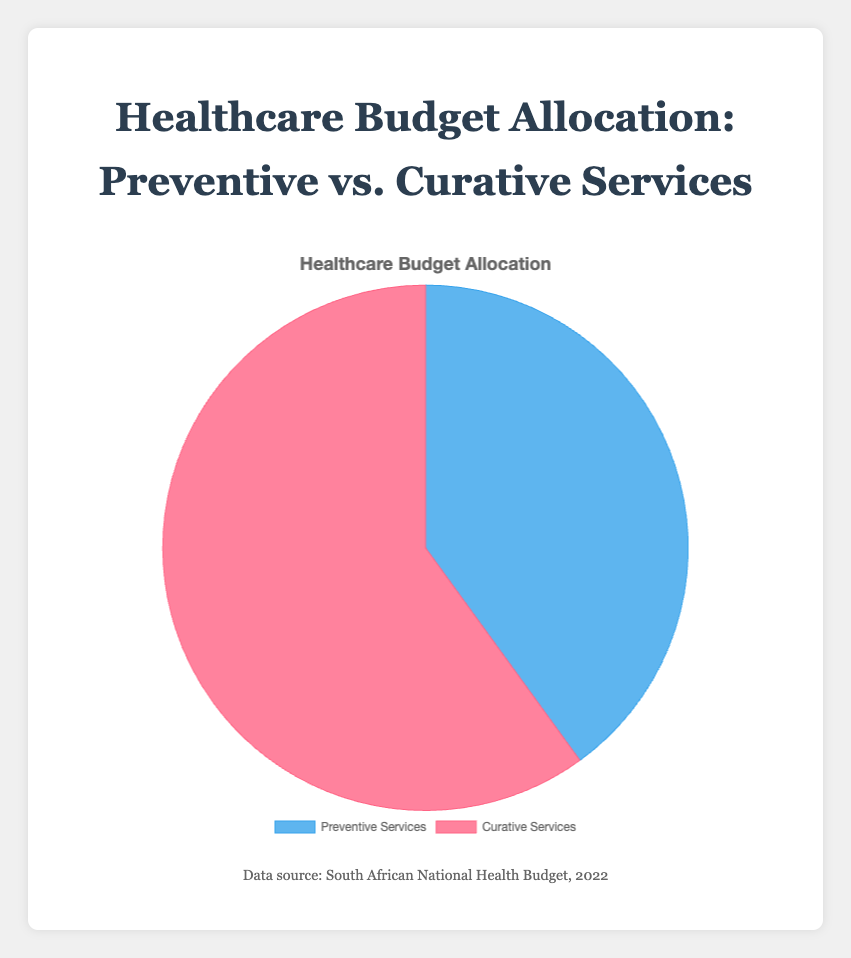What percentage of the healthcare budget is allocated to Preventive Services? The pie chart shows that 40% of the healthcare budget is allocated to Preventive Services.
Answer: 40% Is more of the healthcare budget allocated to Preventive or Curative Services? By comparing the sections of the pie chart, it is clear that Curative Services (60%) receive more of the healthcare budget than Preventive Services (40%).
Answer: Curative Services What is the difference in the budget allocation percentages between Preventive and Curative Services? The pie chart shows Preventive Services at 40% and Curative Services at 60%. The difference is 60% - 40% = 20%.
Answer: 20% If the total healthcare budget was $100 million, how much would be allocated to Curative Services? Curative Services receive 60% of the total budget. If the total budget is $100 million, then 60% of $100 million is $60 million.
Answer: $60 million Which category has a smaller budget percentage? Preventive Services have a smaller budget percentage (40%) compared to Curative Services (60%).
Answer: Preventive Services What is the combined percentage of the budget allocated to both Preventive and Curative Services? The pie chart shows that Preventive Services have 40% and Curative Services have 60%. The combined percentage is 40% + 60% = 100%.
Answer: 100% What color represents Curative Services in the pie chart? Visual inspection of the chart shows that Curative Services are represented by the red segment.
Answer: Red If an additional 10% of the budget were allocated to Preventive Services from Curative Services, what would the new percentages be? Currently, Preventive Services have 40% and Curative Services have 60%. If 10% shifts from Curative to Preventive, the new percentages would be Preventive: 40% + 10% = 50%, and Curative: 60% - 10% = 50%.
Answer: Preventive: 50%, Curative: 50% Calculate the ratio of the budget allocations between Curative and Preventive Services. The pie chart shows Curative Services at 60% and Preventive Services at 40%. The ratio is 60% / 40% = 1.5.
Answer: 1.5 If Curative Services had only 50% of the budget, how would this change the percentage allocated to Preventive Services? If Curative Services are reduced to 50%, given the total must be 100%, Preventive Services would then be 100% - 50% = 50%.
Answer: 50% 